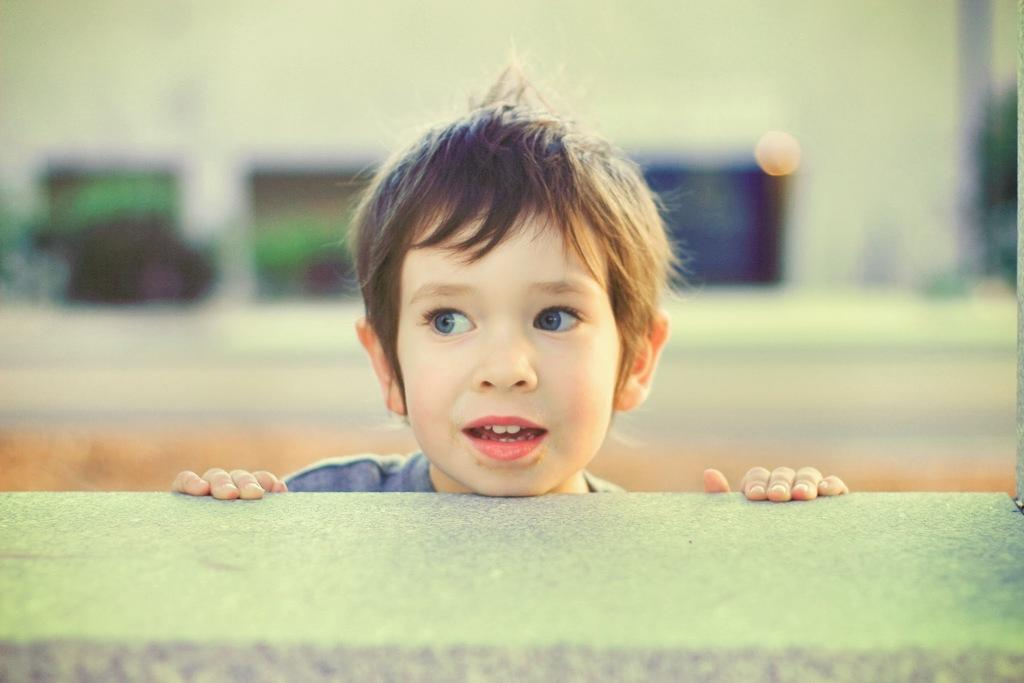What is the main subject of the image? There is a child in the image. Where is the child located in the image? The child is in the middle of the image. What can be seen in the background of the image? The background of the image is blurry. Is there any structure or object visible in the image? Yes, there is a wall in the image. How much grip does the child have on the muscle in the image? There is no muscle or any reference to grip in the image; it only features a child in the middle of the image with a blurry background and a wall. 